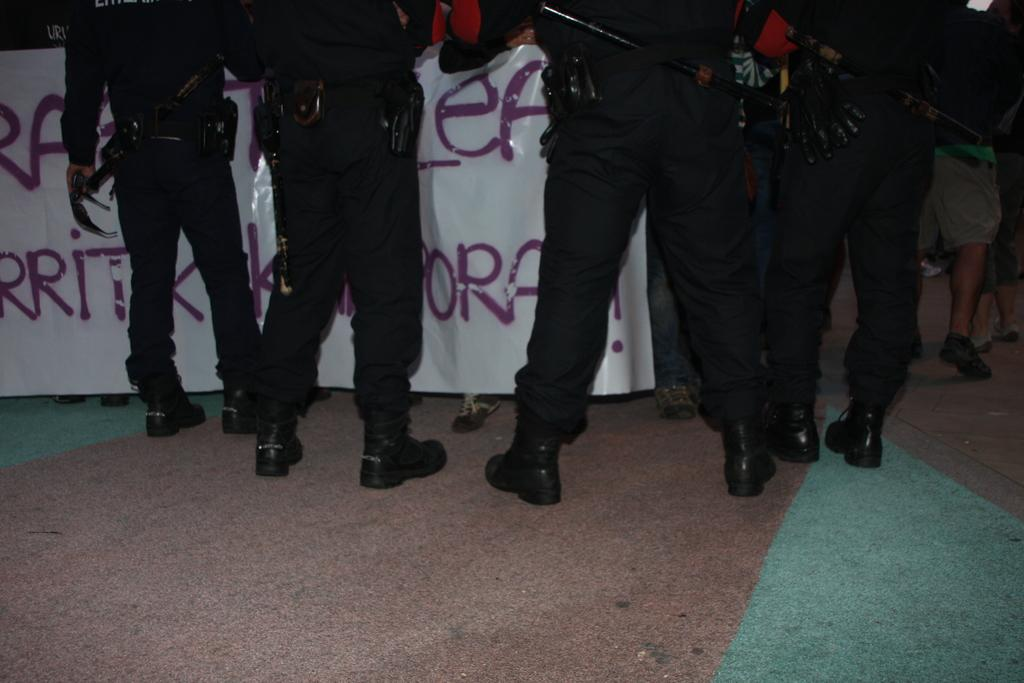Who or what can be seen in the image? There are persons visible in the image. What is the background or setting of the image? The persons are in front of a banner. What is written or depicted on the banner? There is text on the banner. Where are the persons located in relation to the banner? The persons are visible on the floor. What type of flower can be seen growing on the persons in the image? There are no flowers visible on the persons in the image. What is the weight of the quince that the persons are holding in the image? There are no quinces present in the image, so it is not possible to determine their weight. 